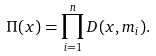<formula> <loc_0><loc_0><loc_500><loc_500>\Pi ( x ) = \prod _ { i = 1 } ^ { n } D ( x , m _ { i } ) .</formula> 